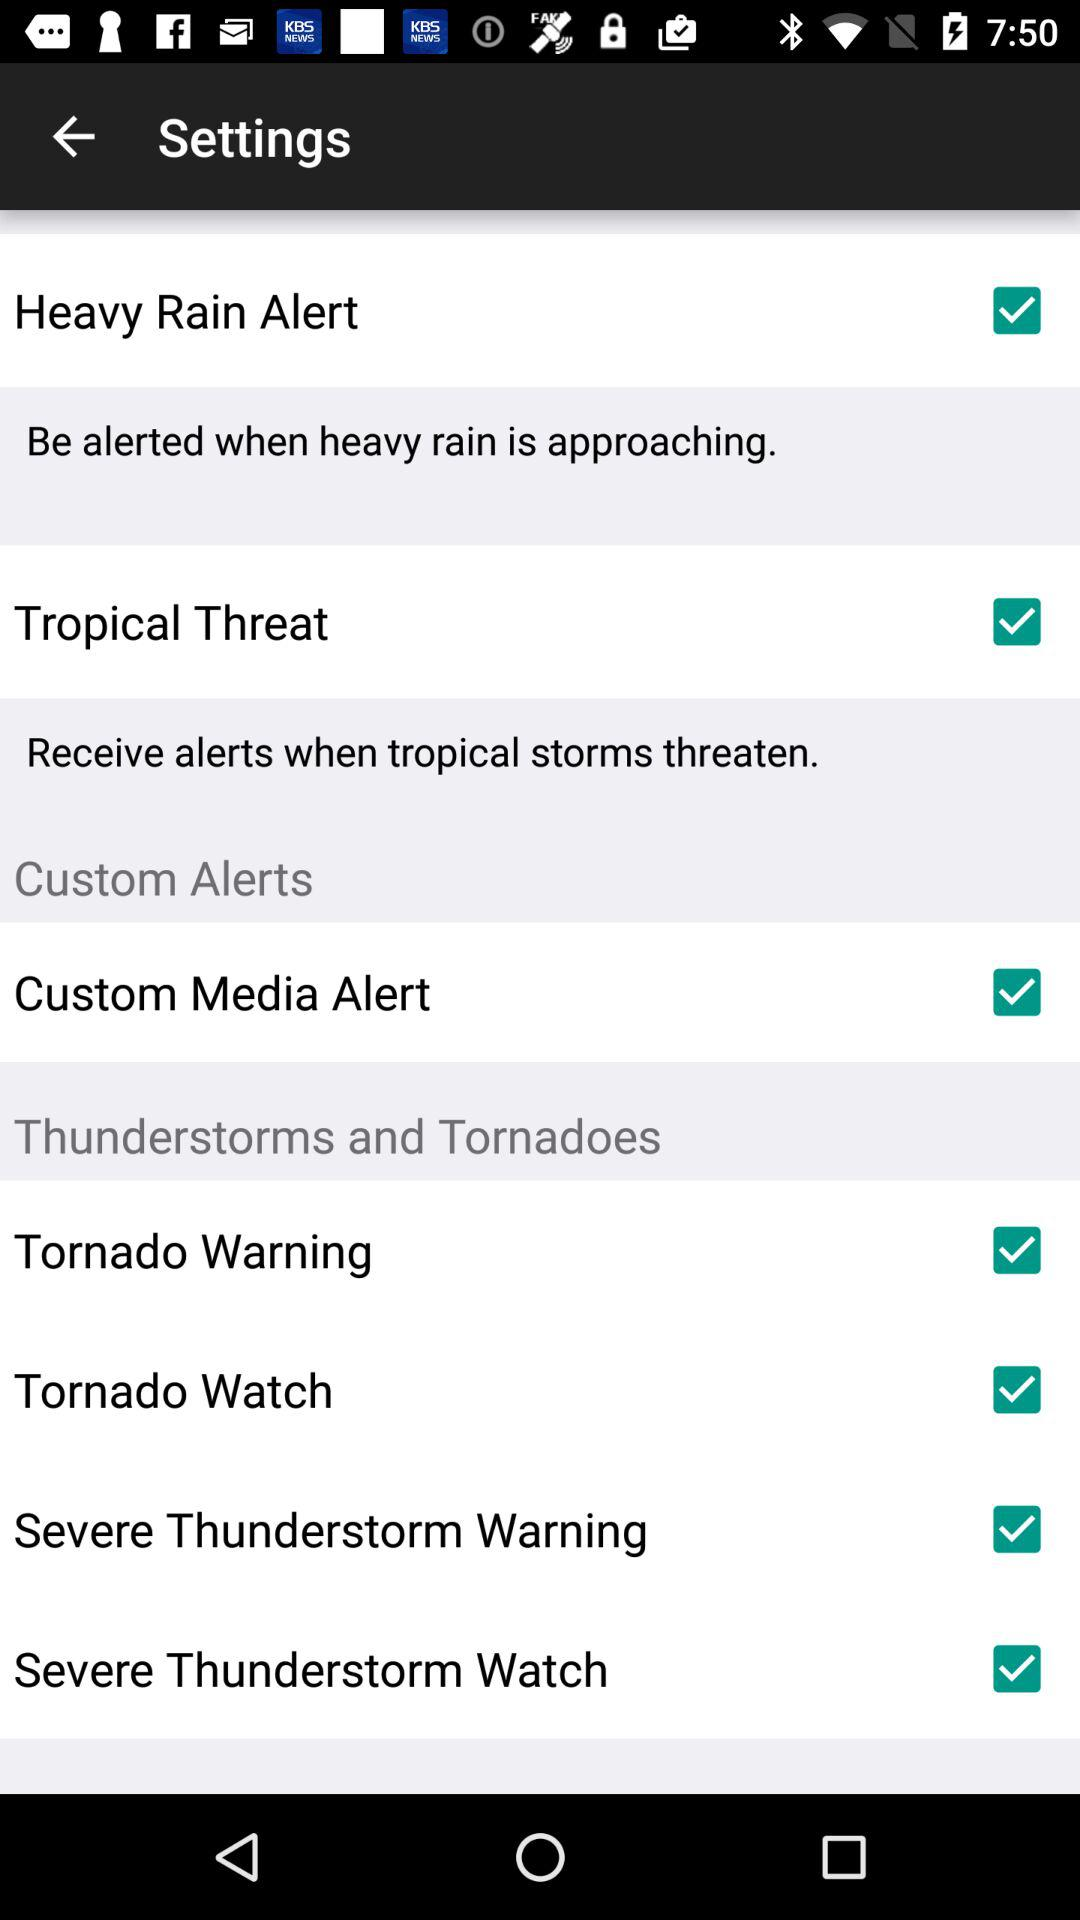What is the status of the "Heavy Rain Alert"? The status of the "Heavy Rain Alert" is "on". 